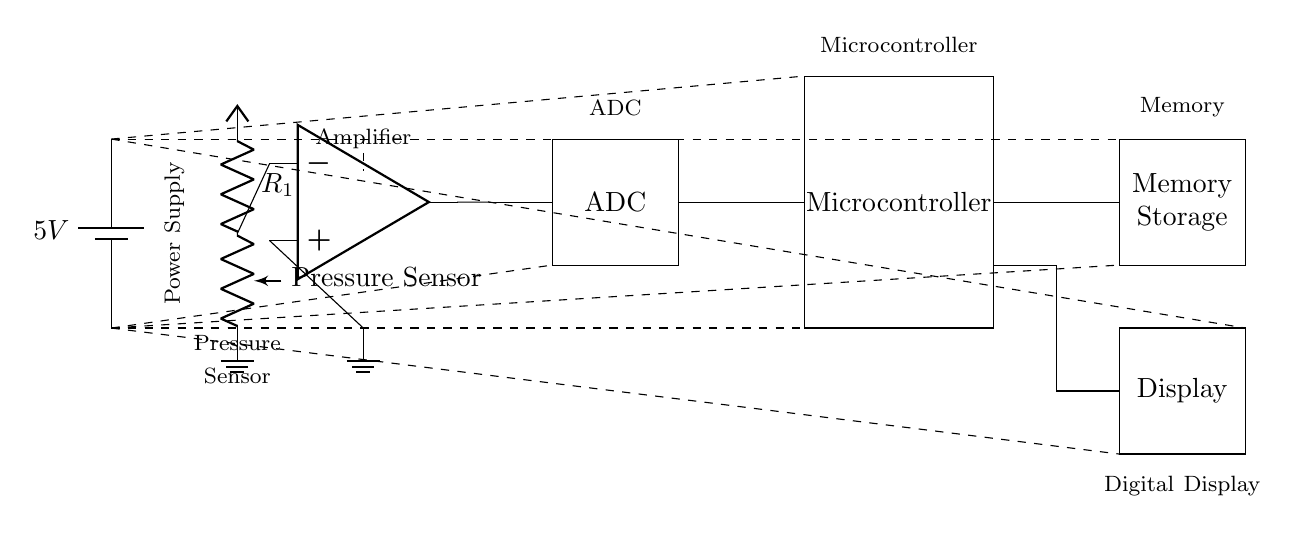What voltage is supplied to this circuit? The circuit is powered by a battery that provides a voltage of 5V, as indicated at the top left of the diagram next to the battery symbol.
Answer: 5V What component converts the analog signal from the pressure sensor? The component that converts the analog signal to a digital format is the Analog-to-Digital Converter (ADC), which is represented as a rectangle labeled ADC in the circuit.
Answer: ADC How does the pressure sensor connect to the amplifier? The pressure sensor connects to the amplifier through a resistor, indicated by the connection that leads from the pressure sensor to the input of the operational amplifier.
Answer: Through a resistor What is the purpose of the microcontroller in this circuit? The microcontroller processes the digital data received from the ADC and controls the overall operation of the blood pressure monitor, such as triggering measurements and displaying results.
Answer: Data processing Which component is responsible for storing memory? The component responsible for memory storage is labeled as Memory Storage, which is depicted as a rectangle in the circuit diagram.
Answer: Memory Storage What is the ground reference point for this circuit? The ground reference point in this circuit is indicated by the ground symbol at the bottom of the circuit, with multiple connections leading to various components, marking the return path for electrical current.
Answer: Ground How does the stored data get displayed? The stored data is displayed on the digital display, which is connected to the microcontroller, allowing for user-readable output of the measurements taken from the pressure sensor.
Answer: Digital display 